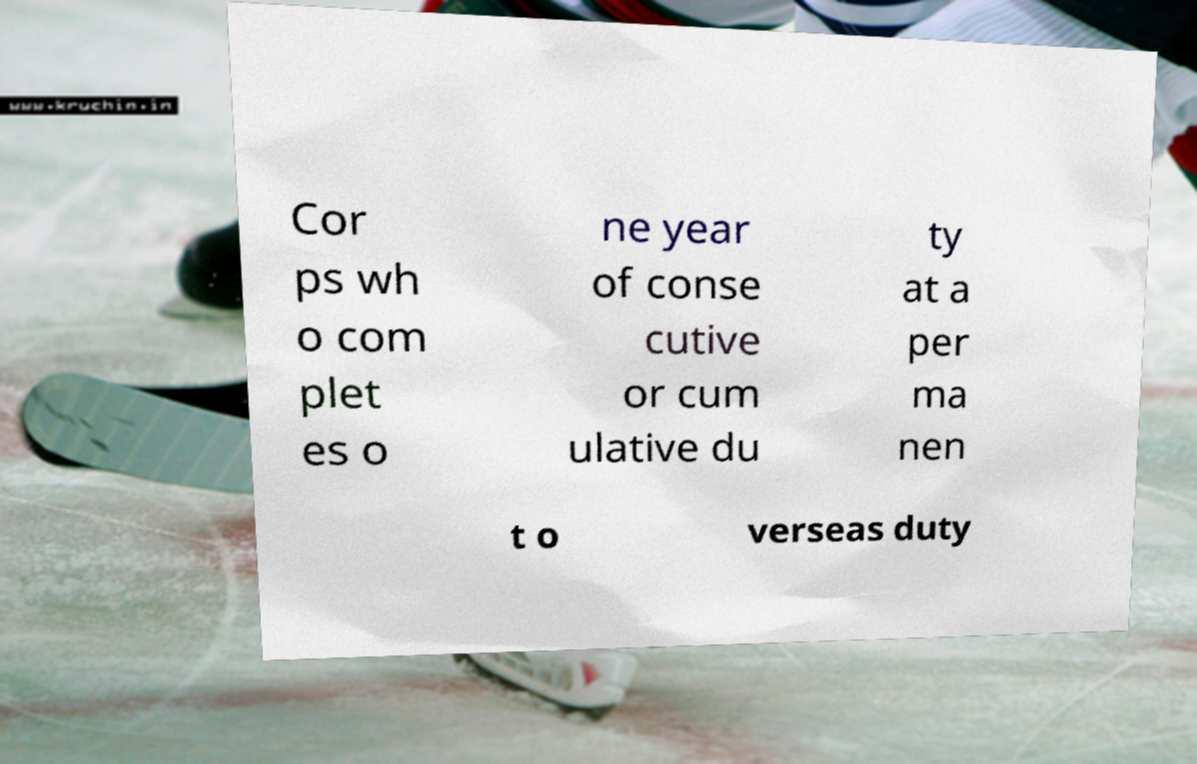I need the written content from this picture converted into text. Can you do that? Cor ps wh o com plet es o ne year of conse cutive or cum ulative du ty at a per ma nen t o verseas duty 